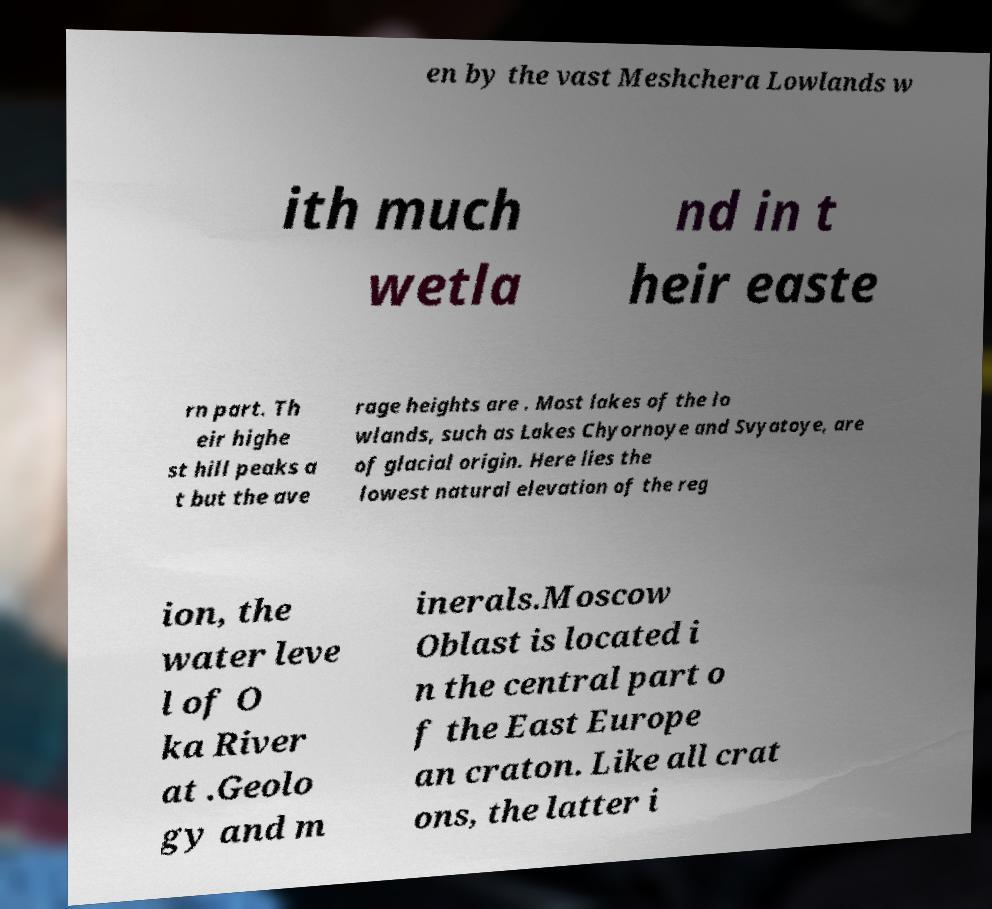I need the written content from this picture converted into text. Can you do that? en by the vast Meshchera Lowlands w ith much wetla nd in t heir easte rn part. Th eir highe st hill peaks a t but the ave rage heights are . Most lakes of the lo wlands, such as Lakes Chyornoye and Svyatoye, are of glacial origin. Here lies the lowest natural elevation of the reg ion, the water leve l of O ka River at .Geolo gy and m inerals.Moscow Oblast is located i n the central part o f the East Europe an craton. Like all crat ons, the latter i 